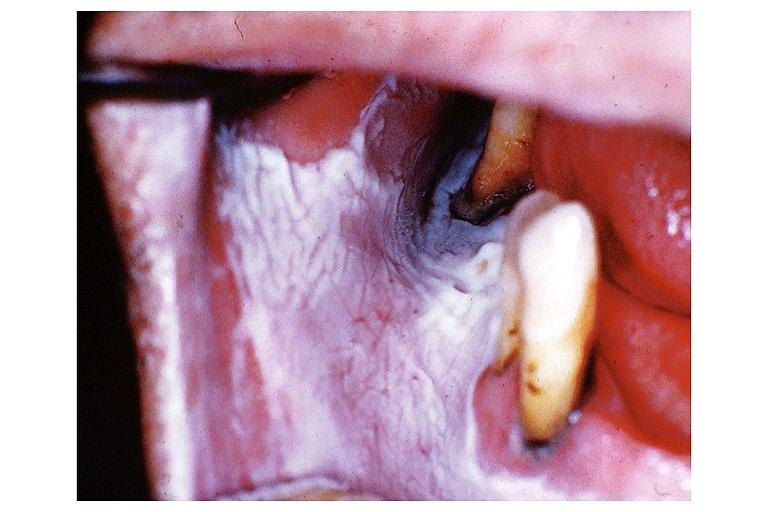where is this?
Answer the question using a single word or phrase. Oral 